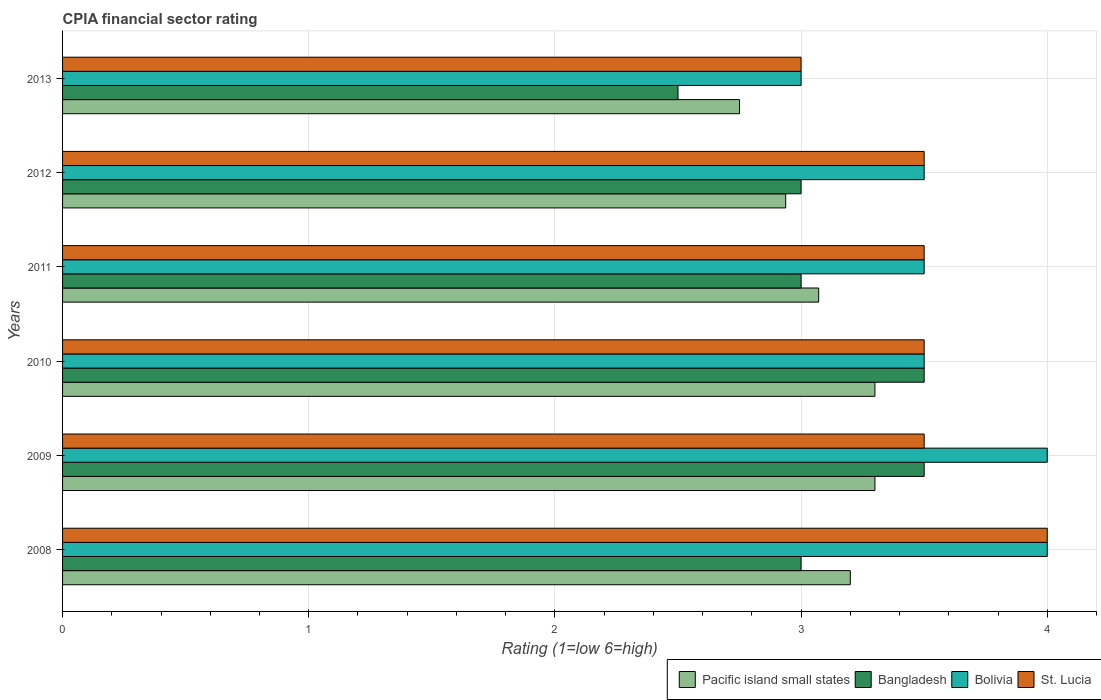How many groups of bars are there?
Provide a short and direct response. 6. Are the number of bars per tick equal to the number of legend labels?
Ensure brevity in your answer.  Yes. In how many cases, is the number of bars for a given year not equal to the number of legend labels?
Offer a very short reply. 0. In which year was the CPIA rating in Bangladesh maximum?
Make the answer very short. 2009. In which year was the CPIA rating in Bangladesh minimum?
Your answer should be compact. 2013. What is the total CPIA rating in Pacific island small states in the graph?
Offer a very short reply. 18.56. What is the difference between the CPIA rating in Pacific island small states in 2010 and the CPIA rating in Bangladesh in 2009?
Give a very brief answer. -0.2. What is the average CPIA rating in Bangladesh per year?
Your response must be concise. 3.08. In the year 2012, what is the difference between the CPIA rating in Bangladesh and CPIA rating in St. Lucia?
Your answer should be very brief. -0.5. What is the ratio of the CPIA rating in Bolivia in 2009 to that in 2010?
Provide a short and direct response. 1.14. Is the difference between the CPIA rating in Bangladesh in 2008 and 2011 greater than the difference between the CPIA rating in St. Lucia in 2008 and 2011?
Offer a terse response. No. What is the difference between the highest and the lowest CPIA rating in Pacific island small states?
Your answer should be compact. 0.55. In how many years, is the CPIA rating in Bolivia greater than the average CPIA rating in Bolivia taken over all years?
Your answer should be compact. 2. Is it the case that in every year, the sum of the CPIA rating in Bangladesh and CPIA rating in Bolivia is greater than the sum of CPIA rating in Pacific island small states and CPIA rating in St. Lucia?
Keep it short and to the point. No. What does the 3rd bar from the bottom in 2009 represents?
Your response must be concise. Bolivia. What is the difference between two consecutive major ticks on the X-axis?
Offer a terse response. 1. Are the values on the major ticks of X-axis written in scientific E-notation?
Ensure brevity in your answer.  No. Does the graph contain any zero values?
Provide a short and direct response. No. Does the graph contain grids?
Give a very brief answer. Yes. Where does the legend appear in the graph?
Keep it short and to the point. Bottom right. How many legend labels are there?
Provide a succinct answer. 4. What is the title of the graph?
Provide a short and direct response. CPIA financial sector rating. Does "Egypt, Arab Rep." appear as one of the legend labels in the graph?
Make the answer very short. No. What is the label or title of the X-axis?
Give a very brief answer. Rating (1=low 6=high). What is the label or title of the Y-axis?
Provide a short and direct response. Years. What is the Rating (1=low 6=high) in Pacific island small states in 2008?
Your answer should be very brief. 3.2. What is the Rating (1=low 6=high) of Bolivia in 2008?
Provide a short and direct response. 4. What is the Rating (1=low 6=high) of Pacific island small states in 2009?
Provide a short and direct response. 3.3. What is the Rating (1=low 6=high) in St. Lucia in 2009?
Keep it short and to the point. 3.5. What is the Rating (1=low 6=high) of Pacific island small states in 2010?
Ensure brevity in your answer.  3.3. What is the Rating (1=low 6=high) of Pacific island small states in 2011?
Your response must be concise. 3.07. What is the Rating (1=low 6=high) in Bangladesh in 2011?
Keep it short and to the point. 3. What is the Rating (1=low 6=high) in Bolivia in 2011?
Your answer should be compact. 3.5. What is the Rating (1=low 6=high) of St. Lucia in 2011?
Provide a short and direct response. 3.5. What is the Rating (1=low 6=high) of Pacific island small states in 2012?
Ensure brevity in your answer.  2.94. What is the Rating (1=low 6=high) in St. Lucia in 2012?
Provide a short and direct response. 3.5. What is the Rating (1=low 6=high) in Pacific island small states in 2013?
Provide a succinct answer. 2.75. What is the Rating (1=low 6=high) in Bangladesh in 2013?
Your answer should be very brief. 2.5. What is the Rating (1=low 6=high) of Bolivia in 2013?
Offer a terse response. 3. What is the Rating (1=low 6=high) of St. Lucia in 2013?
Ensure brevity in your answer.  3. Across all years, what is the maximum Rating (1=low 6=high) of Bangladesh?
Ensure brevity in your answer.  3.5. Across all years, what is the minimum Rating (1=low 6=high) of Pacific island small states?
Ensure brevity in your answer.  2.75. Across all years, what is the minimum Rating (1=low 6=high) in Bangladesh?
Give a very brief answer. 2.5. Across all years, what is the minimum Rating (1=low 6=high) in Bolivia?
Your response must be concise. 3. What is the total Rating (1=low 6=high) in Pacific island small states in the graph?
Make the answer very short. 18.56. What is the total Rating (1=low 6=high) in Bangladesh in the graph?
Offer a terse response. 18.5. What is the total Rating (1=low 6=high) of Bolivia in the graph?
Make the answer very short. 21.5. What is the difference between the Rating (1=low 6=high) in Pacific island small states in 2008 and that in 2009?
Ensure brevity in your answer.  -0.1. What is the difference between the Rating (1=low 6=high) in Bangladesh in 2008 and that in 2009?
Your answer should be compact. -0.5. What is the difference between the Rating (1=low 6=high) in St. Lucia in 2008 and that in 2009?
Give a very brief answer. 0.5. What is the difference between the Rating (1=low 6=high) of Bangladesh in 2008 and that in 2010?
Keep it short and to the point. -0.5. What is the difference between the Rating (1=low 6=high) of St. Lucia in 2008 and that in 2010?
Give a very brief answer. 0.5. What is the difference between the Rating (1=low 6=high) in Pacific island small states in 2008 and that in 2011?
Provide a short and direct response. 0.13. What is the difference between the Rating (1=low 6=high) in Bangladesh in 2008 and that in 2011?
Make the answer very short. 0. What is the difference between the Rating (1=low 6=high) in St. Lucia in 2008 and that in 2011?
Offer a terse response. 0.5. What is the difference between the Rating (1=low 6=high) in Pacific island small states in 2008 and that in 2012?
Make the answer very short. 0.26. What is the difference between the Rating (1=low 6=high) in Pacific island small states in 2008 and that in 2013?
Keep it short and to the point. 0.45. What is the difference between the Rating (1=low 6=high) in Bangladesh in 2008 and that in 2013?
Your answer should be very brief. 0.5. What is the difference between the Rating (1=low 6=high) of St. Lucia in 2008 and that in 2013?
Make the answer very short. 1. What is the difference between the Rating (1=low 6=high) in Bolivia in 2009 and that in 2010?
Your answer should be compact. 0.5. What is the difference between the Rating (1=low 6=high) of St. Lucia in 2009 and that in 2010?
Your answer should be compact. 0. What is the difference between the Rating (1=low 6=high) of Pacific island small states in 2009 and that in 2011?
Your answer should be compact. 0.23. What is the difference between the Rating (1=low 6=high) in Bangladesh in 2009 and that in 2011?
Ensure brevity in your answer.  0.5. What is the difference between the Rating (1=low 6=high) in St. Lucia in 2009 and that in 2011?
Offer a terse response. 0. What is the difference between the Rating (1=low 6=high) in Pacific island small states in 2009 and that in 2012?
Keep it short and to the point. 0.36. What is the difference between the Rating (1=low 6=high) in Bangladesh in 2009 and that in 2012?
Give a very brief answer. 0.5. What is the difference between the Rating (1=low 6=high) of Bolivia in 2009 and that in 2012?
Keep it short and to the point. 0.5. What is the difference between the Rating (1=low 6=high) of St. Lucia in 2009 and that in 2012?
Offer a very short reply. 0. What is the difference between the Rating (1=low 6=high) of Pacific island small states in 2009 and that in 2013?
Your answer should be compact. 0.55. What is the difference between the Rating (1=low 6=high) of Bangladesh in 2009 and that in 2013?
Your answer should be very brief. 1. What is the difference between the Rating (1=low 6=high) in Pacific island small states in 2010 and that in 2011?
Offer a terse response. 0.23. What is the difference between the Rating (1=low 6=high) in Bolivia in 2010 and that in 2011?
Provide a short and direct response. 0. What is the difference between the Rating (1=low 6=high) of Pacific island small states in 2010 and that in 2012?
Provide a succinct answer. 0.36. What is the difference between the Rating (1=low 6=high) in St. Lucia in 2010 and that in 2012?
Your answer should be compact. 0. What is the difference between the Rating (1=low 6=high) in Pacific island small states in 2010 and that in 2013?
Make the answer very short. 0.55. What is the difference between the Rating (1=low 6=high) of Bangladesh in 2010 and that in 2013?
Give a very brief answer. 1. What is the difference between the Rating (1=low 6=high) of St. Lucia in 2010 and that in 2013?
Your answer should be compact. 0.5. What is the difference between the Rating (1=low 6=high) of Pacific island small states in 2011 and that in 2012?
Offer a terse response. 0.13. What is the difference between the Rating (1=low 6=high) of Bolivia in 2011 and that in 2012?
Provide a short and direct response. 0. What is the difference between the Rating (1=low 6=high) of Pacific island small states in 2011 and that in 2013?
Provide a short and direct response. 0.32. What is the difference between the Rating (1=low 6=high) in St. Lucia in 2011 and that in 2013?
Your response must be concise. 0.5. What is the difference between the Rating (1=low 6=high) in Pacific island small states in 2012 and that in 2013?
Your answer should be very brief. 0.19. What is the difference between the Rating (1=low 6=high) in Bangladesh in 2012 and that in 2013?
Keep it short and to the point. 0.5. What is the difference between the Rating (1=low 6=high) in Bolivia in 2012 and that in 2013?
Your answer should be very brief. 0.5. What is the difference between the Rating (1=low 6=high) of St. Lucia in 2012 and that in 2013?
Keep it short and to the point. 0.5. What is the difference between the Rating (1=low 6=high) in Pacific island small states in 2008 and the Rating (1=low 6=high) in St. Lucia in 2009?
Provide a succinct answer. -0.3. What is the difference between the Rating (1=low 6=high) in Bangladesh in 2008 and the Rating (1=low 6=high) in Bolivia in 2009?
Your response must be concise. -1. What is the difference between the Rating (1=low 6=high) in Pacific island small states in 2008 and the Rating (1=low 6=high) in Bangladesh in 2010?
Keep it short and to the point. -0.3. What is the difference between the Rating (1=low 6=high) in Pacific island small states in 2008 and the Rating (1=low 6=high) in Bolivia in 2010?
Give a very brief answer. -0.3. What is the difference between the Rating (1=low 6=high) of Pacific island small states in 2008 and the Rating (1=low 6=high) of St. Lucia in 2010?
Ensure brevity in your answer.  -0.3. What is the difference between the Rating (1=low 6=high) in Pacific island small states in 2008 and the Rating (1=low 6=high) in Bangladesh in 2011?
Offer a very short reply. 0.2. What is the difference between the Rating (1=low 6=high) in Pacific island small states in 2008 and the Rating (1=low 6=high) in Bolivia in 2011?
Provide a succinct answer. -0.3. What is the difference between the Rating (1=low 6=high) of Pacific island small states in 2008 and the Rating (1=low 6=high) of St. Lucia in 2011?
Make the answer very short. -0.3. What is the difference between the Rating (1=low 6=high) of Bolivia in 2008 and the Rating (1=low 6=high) of St. Lucia in 2011?
Your response must be concise. 0.5. What is the difference between the Rating (1=low 6=high) of Pacific island small states in 2008 and the Rating (1=low 6=high) of Bangladesh in 2012?
Provide a short and direct response. 0.2. What is the difference between the Rating (1=low 6=high) in Bangladesh in 2008 and the Rating (1=low 6=high) in St. Lucia in 2012?
Make the answer very short. -0.5. What is the difference between the Rating (1=low 6=high) in Pacific island small states in 2008 and the Rating (1=low 6=high) in Bangladesh in 2013?
Offer a very short reply. 0.7. What is the difference between the Rating (1=low 6=high) in Pacific island small states in 2008 and the Rating (1=low 6=high) in St. Lucia in 2013?
Make the answer very short. 0.2. What is the difference between the Rating (1=low 6=high) of Bolivia in 2008 and the Rating (1=low 6=high) of St. Lucia in 2013?
Give a very brief answer. 1. What is the difference between the Rating (1=low 6=high) in Pacific island small states in 2009 and the Rating (1=low 6=high) in Bangladesh in 2010?
Keep it short and to the point. -0.2. What is the difference between the Rating (1=low 6=high) of Pacific island small states in 2009 and the Rating (1=low 6=high) of St. Lucia in 2010?
Your answer should be compact. -0.2. What is the difference between the Rating (1=low 6=high) of Bangladesh in 2009 and the Rating (1=low 6=high) of St. Lucia in 2010?
Your answer should be compact. 0. What is the difference between the Rating (1=low 6=high) in Pacific island small states in 2009 and the Rating (1=low 6=high) in Bangladesh in 2011?
Your answer should be very brief. 0.3. What is the difference between the Rating (1=low 6=high) in Bangladesh in 2009 and the Rating (1=low 6=high) in Bolivia in 2011?
Your response must be concise. 0. What is the difference between the Rating (1=low 6=high) in Bangladesh in 2009 and the Rating (1=low 6=high) in St. Lucia in 2011?
Your response must be concise. 0. What is the difference between the Rating (1=low 6=high) of Bolivia in 2009 and the Rating (1=low 6=high) of St. Lucia in 2011?
Your answer should be compact. 0.5. What is the difference between the Rating (1=low 6=high) in Pacific island small states in 2009 and the Rating (1=low 6=high) in Bolivia in 2012?
Offer a very short reply. -0.2. What is the difference between the Rating (1=low 6=high) of Pacific island small states in 2009 and the Rating (1=low 6=high) of St. Lucia in 2012?
Keep it short and to the point. -0.2. What is the difference between the Rating (1=low 6=high) in Bangladesh in 2009 and the Rating (1=low 6=high) in St. Lucia in 2012?
Give a very brief answer. 0. What is the difference between the Rating (1=low 6=high) in Pacific island small states in 2009 and the Rating (1=low 6=high) in Bangladesh in 2013?
Provide a short and direct response. 0.8. What is the difference between the Rating (1=low 6=high) of Pacific island small states in 2009 and the Rating (1=low 6=high) of St. Lucia in 2013?
Your answer should be compact. 0.3. What is the difference between the Rating (1=low 6=high) in Bangladesh in 2010 and the Rating (1=low 6=high) in St. Lucia in 2011?
Your answer should be compact. 0. What is the difference between the Rating (1=low 6=high) of Bolivia in 2010 and the Rating (1=low 6=high) of St. Lucia in 2011?
Provide a short and direct response. 0. What is the difference between the Rating (1=low 6=high) in Pacific island small states in 2010 and the Rating (1=low 6=high) in Bangladesh in 2012?
Ensure brevity in your answer.  0.3. What is the difference between the Rating (1=low 6=high) in Pacific island small states in 2010 and the Rating (1=low 6=high) in Bolivia in 2012?
Your response must be concise. -0.2. What is the difference between the Rating (1=low 6=high) of Bangladesh in 2010 and the Rating (1=low 6=high) of Bolivia in 2012?
Your response must be concise. 0. What is the difference between the Rating (1=low 6=high) in Bangladesh in 2010 and the Rating (1=low 6=high) in St. Lucia in 2012?
Offer a very short reply. 0. What is the difference between the Rating (1=low 6=high) of Pacific island small states in 2010 and the Rating (1=low 6=high) of Bangladesh in 2013?
Your answer should be compact. 0.8. What is the difference between the Rating (1=low 6=high) of Pacific island small states in 2010 and the Rating (1=low 6=high) of Bolivia in 2013?
Keep it short and to the point. 0.3. What is the difference between the Rating (1=low 6=high) in Pacific island small states in 2010 and the Rating (1=low 6=high) in St. Lucia in 2013?
Keep it short and to the point. 0.3. What is the difference between the Rating (1=low 6=high) of Bangladesh in 2010 and the Rating (1=low 6=high) of Bolivia in 2013?
Offer a terse response. 0.5. What is the difference between the Rating (1=low 6=high) of Bangladesh in 2010 and the Rating (1=low 6=high) of St. Lucia in 2013?
Ensure brevity in your answer.  0.5. What is the difference between the Rating (1=low 6=high) of Bolivia in 2010 and the Rating (1=low 6=high) of St. Lucia in 2013?
Your answer should be very brief. 0.5. What is the difference between the Rating (1=low 6=high) in Pacific island small states in 2011 and the Rating (1=low 6=high) in Bangladesh in 2012?
Your response must be concise. 0.07. What is the difference between the Rating (1=low 6=high) in Pacific island small states in 2011 and the Rating (1=low 6=high) in Bolivia in 2012?
Make the answer very short. -0.43. What is the difference between the Rating (1=low 6=high) in Pacific island small states in 2011 and the Rating (1=low 6=high) in St. Lucia in 2012?
Offer a very short reply. -0.43. What is the difference between the Rating (1=low 6=high) in Bangladesh in 2011 and the Rating (1=low 6=high) in Bolivia in 2012?
Offer a very short reply. -0.5. What is the difference between the Rating (1=low 6=high) in Bolivia in 2011 and the Rating (1=low 6=high) in St. Lucia in 2012?
Give a very brief answer. 0. What is the difference between the Rating (1=low 6=high) of Pacific island small states in 2011 and the Rating (1=low 6=high) of Bangladesh in 2013?
Make the answer very short. 0.57. What is the difference between the Rating (1=low 6=high) of Pacific island small states in 2011 and the Rating (1=low 6=high) of Bolivia in 2013?
Give a very brief answer. 0.07. What is the difference between the Rating (1=low 6=high) of Pacific island small states in 2011 and the Rating (1=low 6=high) of St. Lucia in 2013?
Give a very brief answer. 0.07. What is the difference between the Rating (1=low 6=high) in Pacific island small states in 2012 and the Rating (1=low 6=high) in Bangladesh in 2013?
Your response must be concise. 0.44. What is the difference between the Rating (1=low 6=high) of Pacific island small states in 2012 and the Rating (1=low 6=high) of Bolivia in 2013?
Keep it short and to the point. -0.06. What is the difference between the Rating (1=low 6=high) of Pacific island small states in 2012 and the Rating (1=low 6=high) of St. Lucia in 2013?
Your answer should be compact. -0.06. What is the difference between the Rating (1=low 6=high) of Bolivia in 2012 and the Rating (1=low 6=high) of St. Lucia in 2013?
Your answer should be compact. 0.5. What is the average Rating (1=low 6=high) in Pacific island small states per year?
Your answer should be compact. 3.09. What is the average Rating (1=low 6=high) in Bangladesh per year?
Keep it short and to the point. 3.08. What is the average Rating (1=low 6=high) of Bolivia per year?
Provide a short and direct response. 3.58. In the year 2008, what is the difference between the Rating (1=low 6=high) of Pacific island small states and Rating (1=low 6=high) of St. Lucia?
Your answer should be very brief. -0.8. In the year 2008, what is the difference between the Rating (1=low 6=high) of Bolivia and Rating (1=low 6=high) of St. Lucia?
Give a very brief answer. 0. In the year 2009, what is the difference between the Rating (1=low 6=high) of Pacific island small states and Rating (1=low 6=high) of Bolivia?
Provide a short and direct response. -0.7. In the year 2009, what is the difference between the Rating (1=low 6=high) of Pacific island small states and Rating (1=low 6=high) of St. Lucia?
Your answer should be compact. -0.2. In the year 2009, what is the difference between the Rating (1=low 6=high) in Bangladesh and Rating (1=low 6=high) in Bolivia?
Keep it short and to the point. -0.5. In the year 2010, what is the difference between the Rating (1=low 6=high) of Bangladesh and Rating (1=low 6=high) of Bolivia?
Keep it short and to the point. 0. In the year 2010, what is the difference between the Rating (1=low 6=high) of Bolivia and Rating (1=low 6=high) of St. Lucia?
Make the answer very short. 0. In the year 2011, what is the difference between the Rating (1=low 6=high) in Pacific island small states and Rating (1=low 6=high) in Bangladesh?
Your answer should be compact. 0.07. In the year 2011, what is the difference between the Rating (1=low 6=high) in Pacific island small states and Rating (1=low 6=high) in Bolivia?
Your answer should be compact. -0.43. In the year 2011, what is the difference between the Rating (1=low 6=high) of Pacific island small states and Rating (1=low 6=high) of St. Lucia?
Provide a short and direct response. -0.43. In the year 2011, what is the difference between the Rating (1=low 6=high) of Bangladesh and Rating (1=low 6=high) of Bolivia?
Your answer should be very brief. -0.5. In the year 2011, what is the difference between the Rating (1=low 6=high) in Bolivia and Rating (1=low 6=high) in St. Lucia?
Offer a very short reply. 0. In the year 2012, what is the difference between the Rating (1=low 6=high) in Pacific island small states and Rating (1=low 6=high) in Bangladesh?
Your answer should be very brief. -0.06. In the year 2012, what is the difference between the Rating (1=low 6=high) in Pacific island small states and Rating (1=low 6=high) in Bolivia?
Your answer should be very brief. -0.56. In the year 2012, what is the difference between the Rating (1=low 6=high) in Pacific island small states and Rating (1=low 6=high) in St. Lucia?
Keep it short and to the point. -0.56. In the year 2012, what is the difference between the Rating (1=low 6=high) in Bangladesh and Rating (1=low 6=high) in St. Lucia?
Provide a short and direct response. -0.5. In the year 2012, what is the difference between the Rating (1=low 6=high) in Bolivia and Rating (1=low 6=high) in St. Lucia?
Your response must be concise. 0. In the year 2013, what is the difference between the Rating (1=low 6=high) of Bangladesh and Rating (1=low 6=high) of St. Lucia?
Provide a succinct answer. -0.5. What is the ratio of the Rating (1=low 6=high) of Pacific island small states in 2008 to that in 2009?
Offer a very short reply. 0.97. What is the ratio of the Rating (1=low 6=high) in Bangladesh in 2008 to that in 2009?
Provide a succinct answer. 0.86. What is the ratio of the Rating (1=low 6=high) in St. Lucia in 2008 to that in 2009?
Provide a short and direct response. 1.14. What is the ratio of the Rating (1=low 6=high) in Pacific island small states in 2008 to that in 2010?
Ensure brevity in your answer.  0.97. What is the ratio of the Rating (1=low 6=high) in Bolivia in 2008 to that in 2010?
Keep it short and to the point. 1.14. What is the ratio of the Rating (1=low 6=high) in St. Lucia in 2008 to that in 2010?
Provide a short and direct response. 1.14. What is the ratio of the Rating (1=low 6=high) in Pacific island small states in 2008 to that in 2011?
Offer a terse response. 1.04. What is the ratio of the Rating (1=low 6=high) of Bangladesh in 2008 to that in 2011?
Your answer should be compact. 1. What is the ratio of the Rating (1=low 6=high) in Pacific island small states in 2008 to that in 2012?
Offer a terse response. 1.09. What is the ratio of the Rating (1=low 6=high) in Bangladesh in 2008 to that in 2012?
Your answer should be compact. 1. What is the ratio of the Rating (1=low 6=high) of Pacific island small states in 2008 to that in 2013?
Keep it short and to the point. 1.16. What is the ratio of the Rating (1=low 6=high) of Bangladesh in 2008 to that in 2013?
Your answer should be compact. 1.2. What is the ratio of the Rating (1=low 6=high) of Bolivia in 2008 to that in 2013?
Offer a very short reply. 1.33. What is the ratio of the Rating (1=low 6=high) in St. Lucia in 2008 to that in 2013?
Your answer should be very brief. 1.33. What is the ratio of the Rating (1=low 6=high) in Bangladesh in 2009 to that in 2010?
Provide a short and direct response. 1. What is the ratio of the Rating (1=low 6=high) of Bolivia in 2009 to that in 2010?
Make the answer very short. 1.14. What is the ratio of the Rating (1=low 6=high) of St. Lucia in 2009 to that in 2010?
Your answer should be compact. 1. What is the ratio of the Rating (1=low 6=high) of Pacific island small states in 2009 to that in 2011?
Your response must be concise. 1.07. What is the ratio of the Rating (1=low 6=high) in Bangladesh in 2009 to that in 2011?
Your answer should be very brief. 1.17. What is the ratio of the Rating (1=low 6=high) of Bolivia in 2009 to that in 2011?
Offer a very short reply. 1.14. What is the ratio of the Rating (1=low 6=high) in Pacific island small states in 2009 to that in 2012?
Make the answer very short. 1.12. What is the ratio of the Rating (1=low 6=high) in Bangladesh in 2009 to that in 2012?
Make the answer very short. 1.17. What is the ratio of the Rating (1=low 6=high) in Pacific island small states in 2009 to that in 2013?
Your answer should be compact. 1.2. What is the ratio of the Rating (1=low 6=high) of Bangladesh in 2009 to that in 2013?
Offer a terse response. 1.4. What is the ratio of the Rating (1=low 6=high) of Bolivia in 2009 to that in 2013?
Your answer should be very brief. 1.33. What is the ratio of the Rating (1=low 6=high) of Pacific island small states in 2010 to that in 2011?
Give a very brief answer. 1.07. What is the ratio of the Rating (1=low 6=high) in Bangladesh in 2010 to that in 2011?
Give a very brief answer. 1.17. What is the ratio of the Rating (1=low 6=high) in Bolivia in 2010 to that in 2011?
Ensure brevity in your answer.  1. What is the ratio of the Rating (1=low 6=high) of St. Lucia in 2010 to that in 2011?
Ensure brevity in your answer.  1. What is the ratio of the Rating (1=low 6=high) in Pacific island small states in 2010 to that in 2012?
Your answer should be compact. 1.12. What is the ratio of the Rating (1=low 6=high) of Bolivia in 2010 to that in 2012?
Your answer should be compact. 1. What is the ratio of the Rating (1=low 6=high) in St. Lucia in 2010 to that in 2012?
Keep it short and to the point. 1. What is the ratio of the Rating (1=low 6=high) in Pacific island small states in 2011 to that in 2012?
Your answer should be compact. 1.05. What is the ratio of the Rating (1=low 6=high) in Bangladesh in 2011 to that in 2012?
Give a very brief answer. 1. What is the ratio of the Rating (1=low 6=high) of Bolivia in 2011 to that in 2012?
Offer a terse response. 1. What is the ratio of the Rating (1=low 6=high) in Pacific island small states in 2011 to that in 2013?
Ensure brevity in your answer.  1.12. What is the ratio of the Rating (1=low 6=high) in Bangladesh in 2011 to that in 2013?
Offer a very short reply. 1.2. What is the ratio of the Rating (1=low 6=high) of Pacific island small states in 2012 to that in 2013?
Your answer should be very brief. 1.07. What is the ratio of the Rating (1=low 6=high) of Bolivia in 2012 to that in 2013?
Give a very brief answer. 1.17. What is the ratio of the Rating (1=low 6=high) of St. Lucia in 2012 to that in 2013?
Your answer should be very brief. 1.17. What is the difference between the highest and the second highest Rating (1=low 6=high) in St. Lucia?
Your answer should be very brief. 0.5. What is the difference between the highest and the lowest Rating (1=low 6=high) in Pacific island small states?
Make the answer very short. 0.55. 